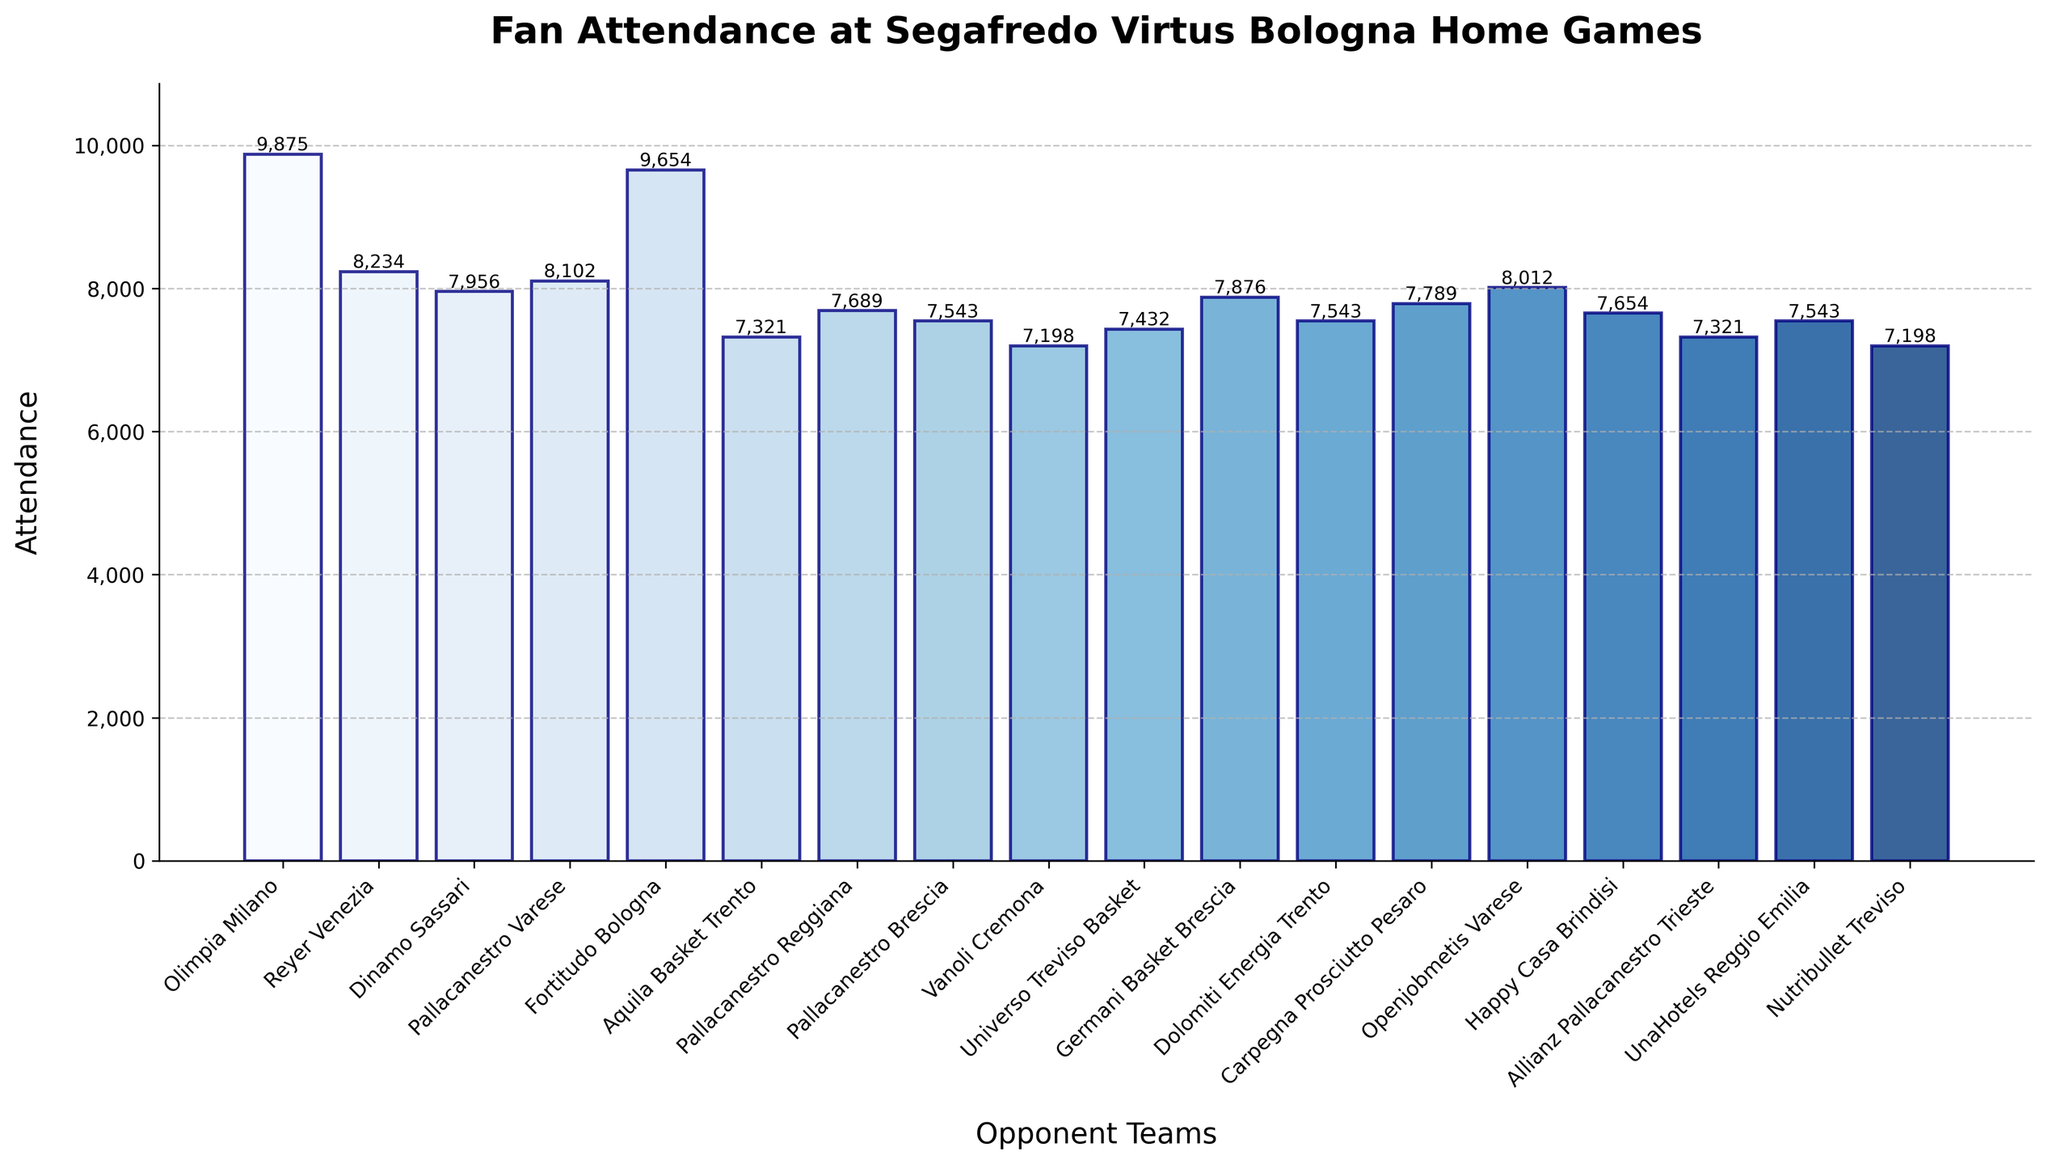What's the highest attendance recorded for an opponent team? Look at the height of each bar to determine which one is the tallest. The tallest bar represents Olimpia Milano. The corresponding label shows an attendance of 9,875.
Answer: Olimpia Milano, 9,875 Which opponent team had the lowest attendance at a home game? Identify the shortest bar, which visually indicates the lowest attendance. The shortest bar represents Vanoli Cremona with an attendance of 7,198.
Answer: Vanoli Cremona, 7,198 What is the total attendance for the games against Fortitudo Bologna, Reyer Venezia, and Dinamo Sassari? Sum the attendance values for these teams: 9,654 (Fortitudo Bologna) + 8,234 (Reyer Venezia) + 7,956 (Dinamo Sassari) = 25,844.
Answer: 25,844 How much higher was the attendance for the game against Olimpia Milano compared to the game against Pallacanestro Varese? Subtract the attendance of Pallacanestro Varese from Olimpia Milano: 9,875 - 8,102 = 1,773.
Answer: 1,773 What is the average attendance across all games? Sum all attendance values and then divide by the number of teams (18). Total sum = 143,424; Average = 143,424 / 18 ≈ 7,968.
Answer: 7,968 Which games had an attendance greater than 8,000? Identify the bars with heights indicating attendance values greater than 8,000. These are Olimpia Milano, Fortitudo Bologna, Reyer Venezia, Pallacanestro Varese, Openjobmetis Varese, and Germani Basket Brescia.
Answer: Olimpia Milano, Fortitudo Bologna, Reyer Venezia, Pallacanestro Varese, Openjobmetis Varese, and Germani Basket Brescia How does the attendance for games against Aquila Basket Trento compare to games against Pallacanestro Reggiana? Compare the bar heights and corresponding values: Aquila Basket Trento has an attendance of 7,321, while Pallacanestro Reggiana has 7,689.
Answer: Pallacanestro Reggiana is higher Which three teams had the closest attendance figures, and what were those figures? Look for bars with heights that appear similar. Pallacanestro Brescia, Dolomiti Energia Trento, and UnaHotels Reggio Emilia each have an attendance of 7,543.
Answer: Pallacanestro Brescia, Dolomiti Energia Trento, and UnaHotels Reggio Emilia; 7,543 each What is the difference in attendance between the highest and lowest attended games? Subtract the lowest attendance from the highest attendance: 9,875 (Olimpia Milano) - 7,198 (Vanoli Cremona) = 2,677.
Answer: 2,677 What is the median attendance for all the home games? First, list all attendance figures in ascending order: 7,198, 7,198, 7,321, 7,321, 7,543, 7,543, 7,543, 7,654, 7,689, 7,789, 7,876, 7,956, 8,012, 8,102, 8,234, 9,654, 9,875. The median of 18 values is the average of the 9th and 10th values: (7,654 + 7,876) / 2 = 7,765.
Answer: 7,765 